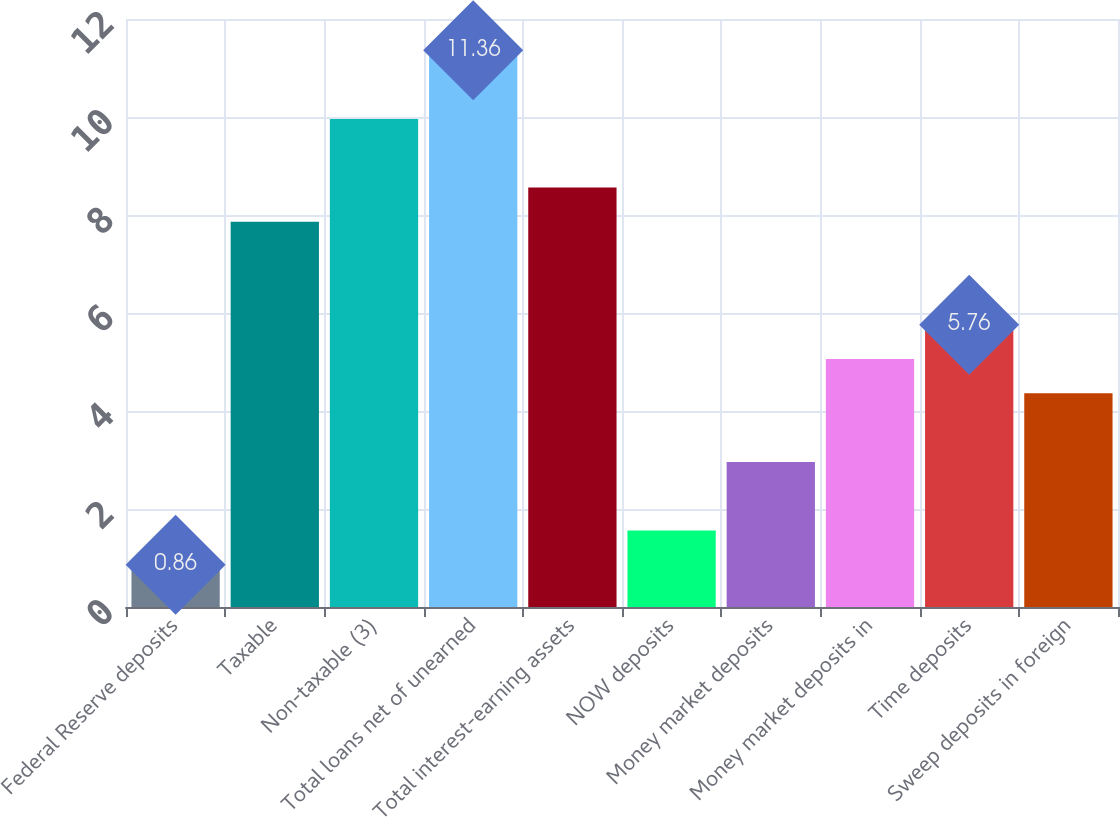Convert chart. <chart><loc_0><loc_0><loc_500><loc_500><bar_chart><fcel>Federal Reserve deposits<fcel>Taxable<fcel>Non-taxable (3)<fcel>Total loans net of unearned<fcel>Total interest-earning assets<fcel>NOW deposits<fcel>Money market deposits<fcel>Money market deposits in<fcel>Time deposits<fcel>Sweep deposits in foreign<nl><fcel>0.86<fcel>7.86<fcel>9.96<fcel>11.36<fcel>8.56<fcel>1.56<fcel>2.96<fcel>5.06<fcel>5.76<fcel>4.36<nl></chart> 